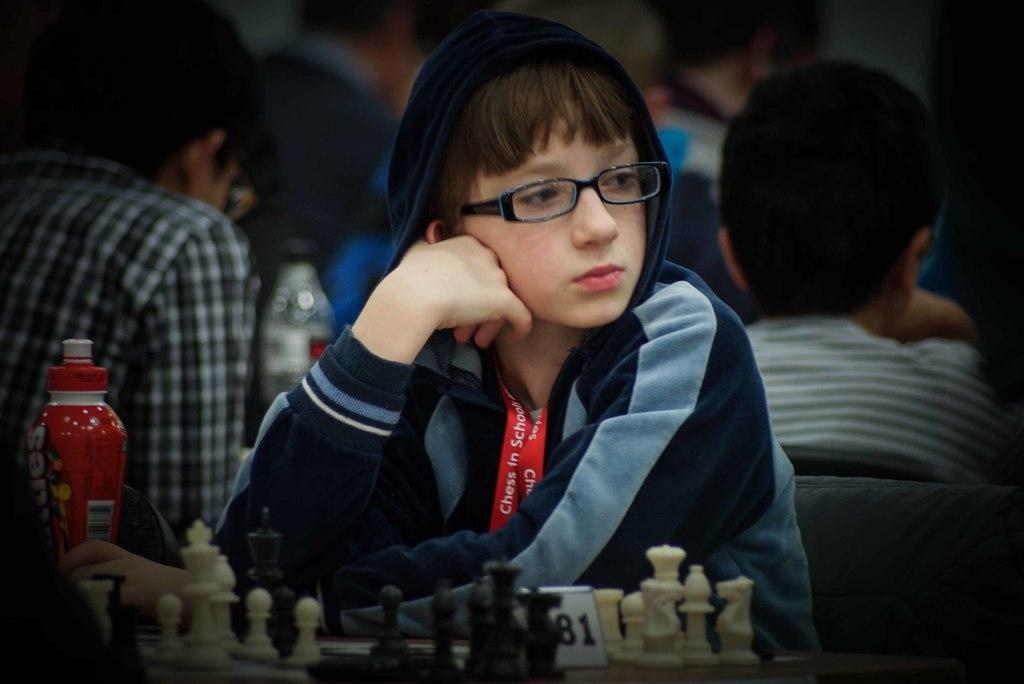What is the person in the image doing? There is a person sitting in the image. What game is being played in the image? There are chess coins in the image, suggesting that a game of chess is being played. What object is on the table in the image? There is a bottle on the table. What can be seen in the background of the image? In the background, there are people sitting. Are there any other bottles visible in the image? Yes, there is another bottle visible in the background. What type of crayon is being used to draw on the stone in the image? There is no crayon or stone present in the image. 